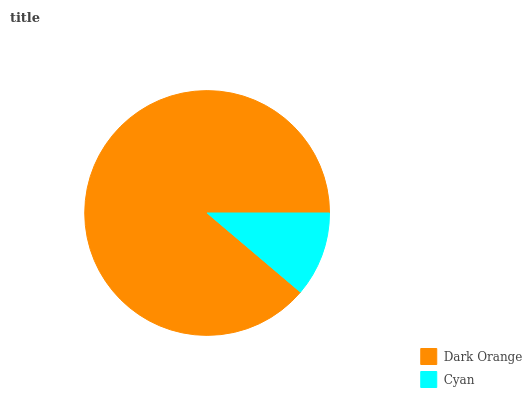Is Cyan the minimum?
Answer yes or no. Yes. Is Dark Orange the maximum?
Answer yes or no. Yes. Is Cyan the maximum?
Answer yes or no. No. Is Dark Orange greater than Cyan?
Answer yes or no. Yes. Is Cyan less than Dark Orange?
Answer yes or no. Yes. Is Cyan greater than Dark Orange?
Answer yes or no. No. Is Dark Orange less than Cyan?
Answer yes or no. No. Is Dark Orange the high median?
Answer yes or no. Yes. Is Cyan the low median?
Answer yes or no. Yes. Is Cyan the high median?
Answer yes or no. No. Is Dark Orange the low median?
Answer yes or no. No. 